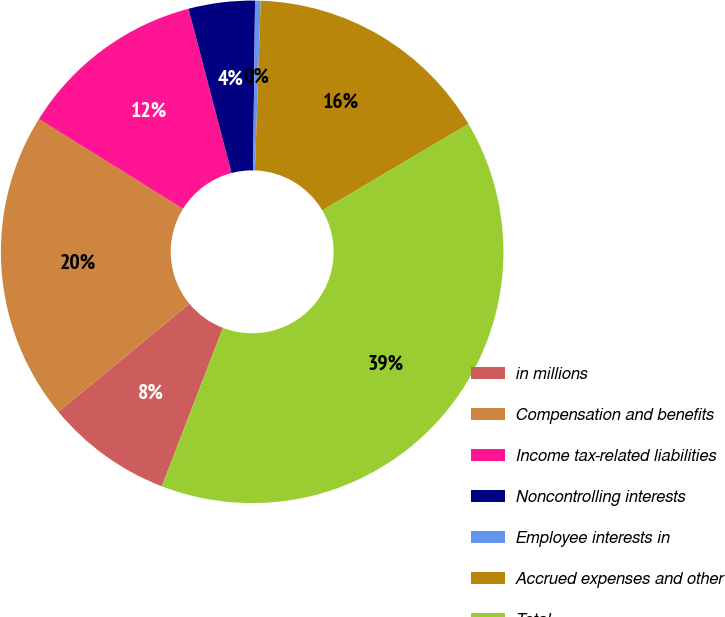Convert chart to OTSL. <chart><loc_0><loc_0><loc_500><loc_500><pie_chart><fcel>in millions<fcel>Compensation and benefits<fcel>Income tax-related liabilities<fcel>Noncontrolling interests<fcel>Employee interests in<fcel>Accrued expenses and other<fcel>Total<nl><fcel>8.16%<fcel>19.85%<fcel>12.06%<fcel>4.26%<fcel>0.36%<fcel>15.96%<fcel>39.35%<nl></chart> 